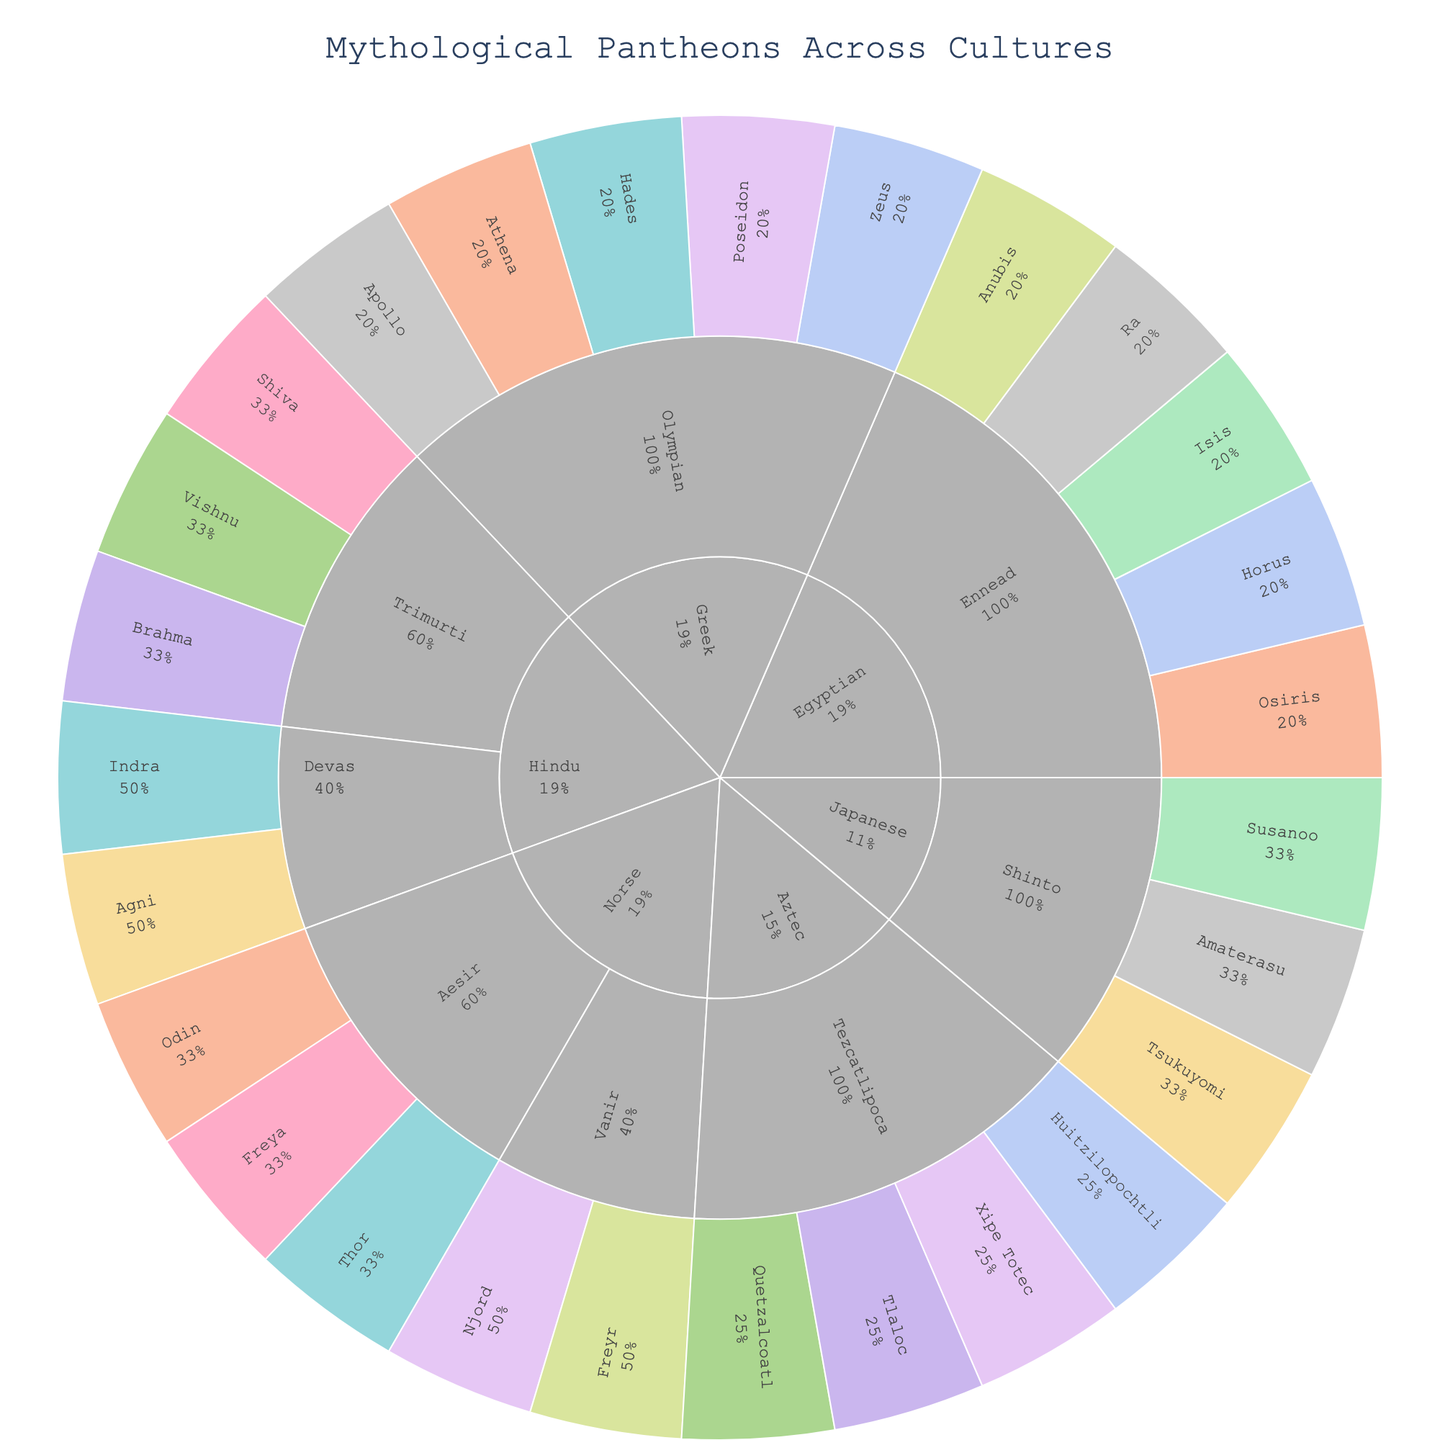How many deities are listed in the Greek pantheon? Check the sunburst plot under the Greek region. Count all the deities directly connected to the Greek outer layer.
Answer: 5 Which type of deity appears most frequently in the Egyptian pantheon? Look at the sunburst plot for the Egyptian region and examine the types of deities. Count the occurrences of each type and identify the most frequent one.
Answer: Sun How many total deities are categorized under the Norse and Hindu regions combined? Summarize the total number of deities by counting the deities in both the Norse and Hindu regions separately and then adding them together.
Answer: 10 Which pantheon has a deity named for the sea in both the Greek and Norse regions? Identify the pantheons within the Greek and Norse regions that have deities named for the sea.
Answer: Olympian (Greek) and Vanir (Norse) What percentage of deities in the Aztec region are associated with agriculture? From the Aztec region, find out how many deities are there in total and how many are associated with agriculture, then calculate the percentage.
Answer: 25% Which region has the highest number of sun-related deities? Examine each region to count the number of sun-related deities and determine which one has the highest count.
Answer: Egyptian In the Japanese Shinto pantheon, which type of deity is associated with both the Sun and Storm? Check the Japanese region under the Shinto pantheon for deities. Identify the types associated with both Sun and Storm.
Answer: Amaterasu (Sun) and Susanoo (Storm) Compare the number of wisdom-related deities between the Greek and Norse pantheons. Which has more? Look at the Greek and Norse regions, count the deities associated with wisdom, then compare the two counts.
Answer: Greek Among the deities in the Hindu Trimurti pantheon, which one is associated with Preservation? Identify the deity in the Hindu Trimurti pantheon that is connected to Preservation.
Answer: Vishnu 